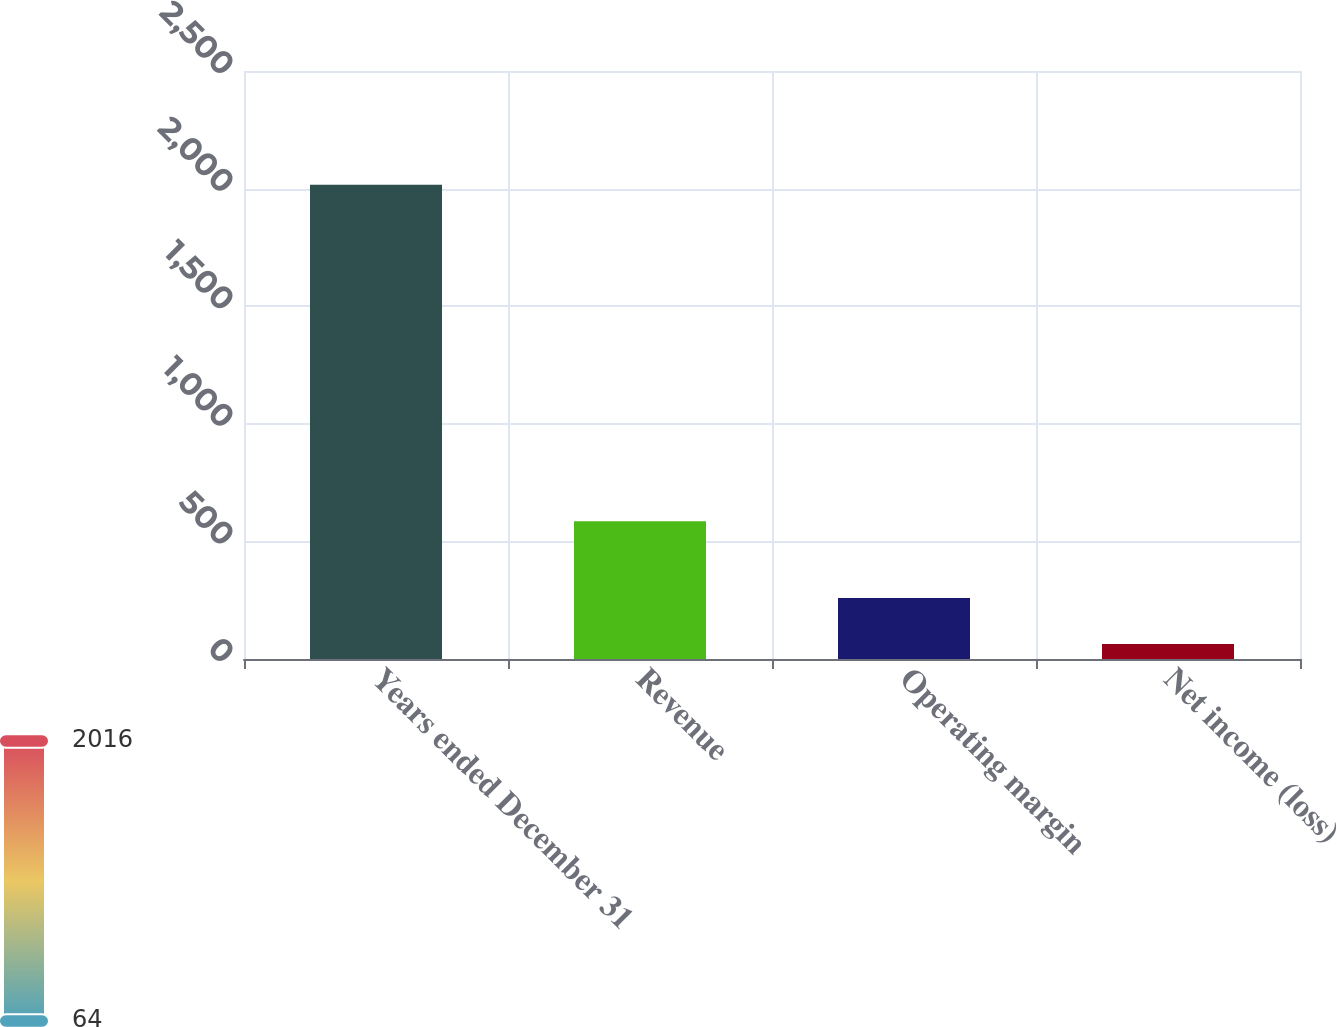<chart> <loc_0><loc_0><loc_500><loc_500><bar_chart><fcel>Years ended December 31<fcel>Revenue<fcel>Operating margin<fcel>Net income (loss)<nl><fcel>2016<fcel>586<fcel>259.2<fcel>64<nl></chart> 